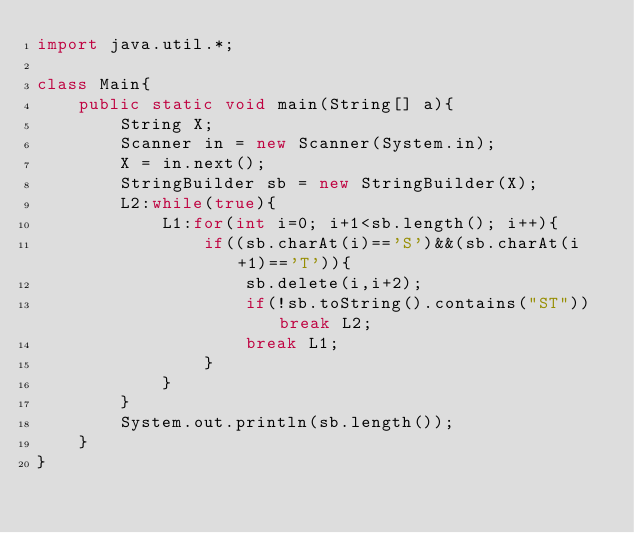Convert code to text. <code><loc_0><loc_0><loc_500><loc_500><_Java_>import java.util.*;
 
class Main{
	public static void main(String[] a){
		String X;
		Scanner in = new Scanner(System.in);
		X = in.next();
		StringBuilder sb = new StringBuilder(X);
		L2:while(true){
			L1:for(int i=0; i+1<sb.length(); i++){
				if((sb.charAt(i)=='S')&&(sb.charAt(i+1)=='T')){
					sb.delete(i,i+2);
					if(!sb.toString().contains("ST")) break L2;
					break L1;
				}
			}
		}
		System.out.println(sb.length());
	}
}</code> 